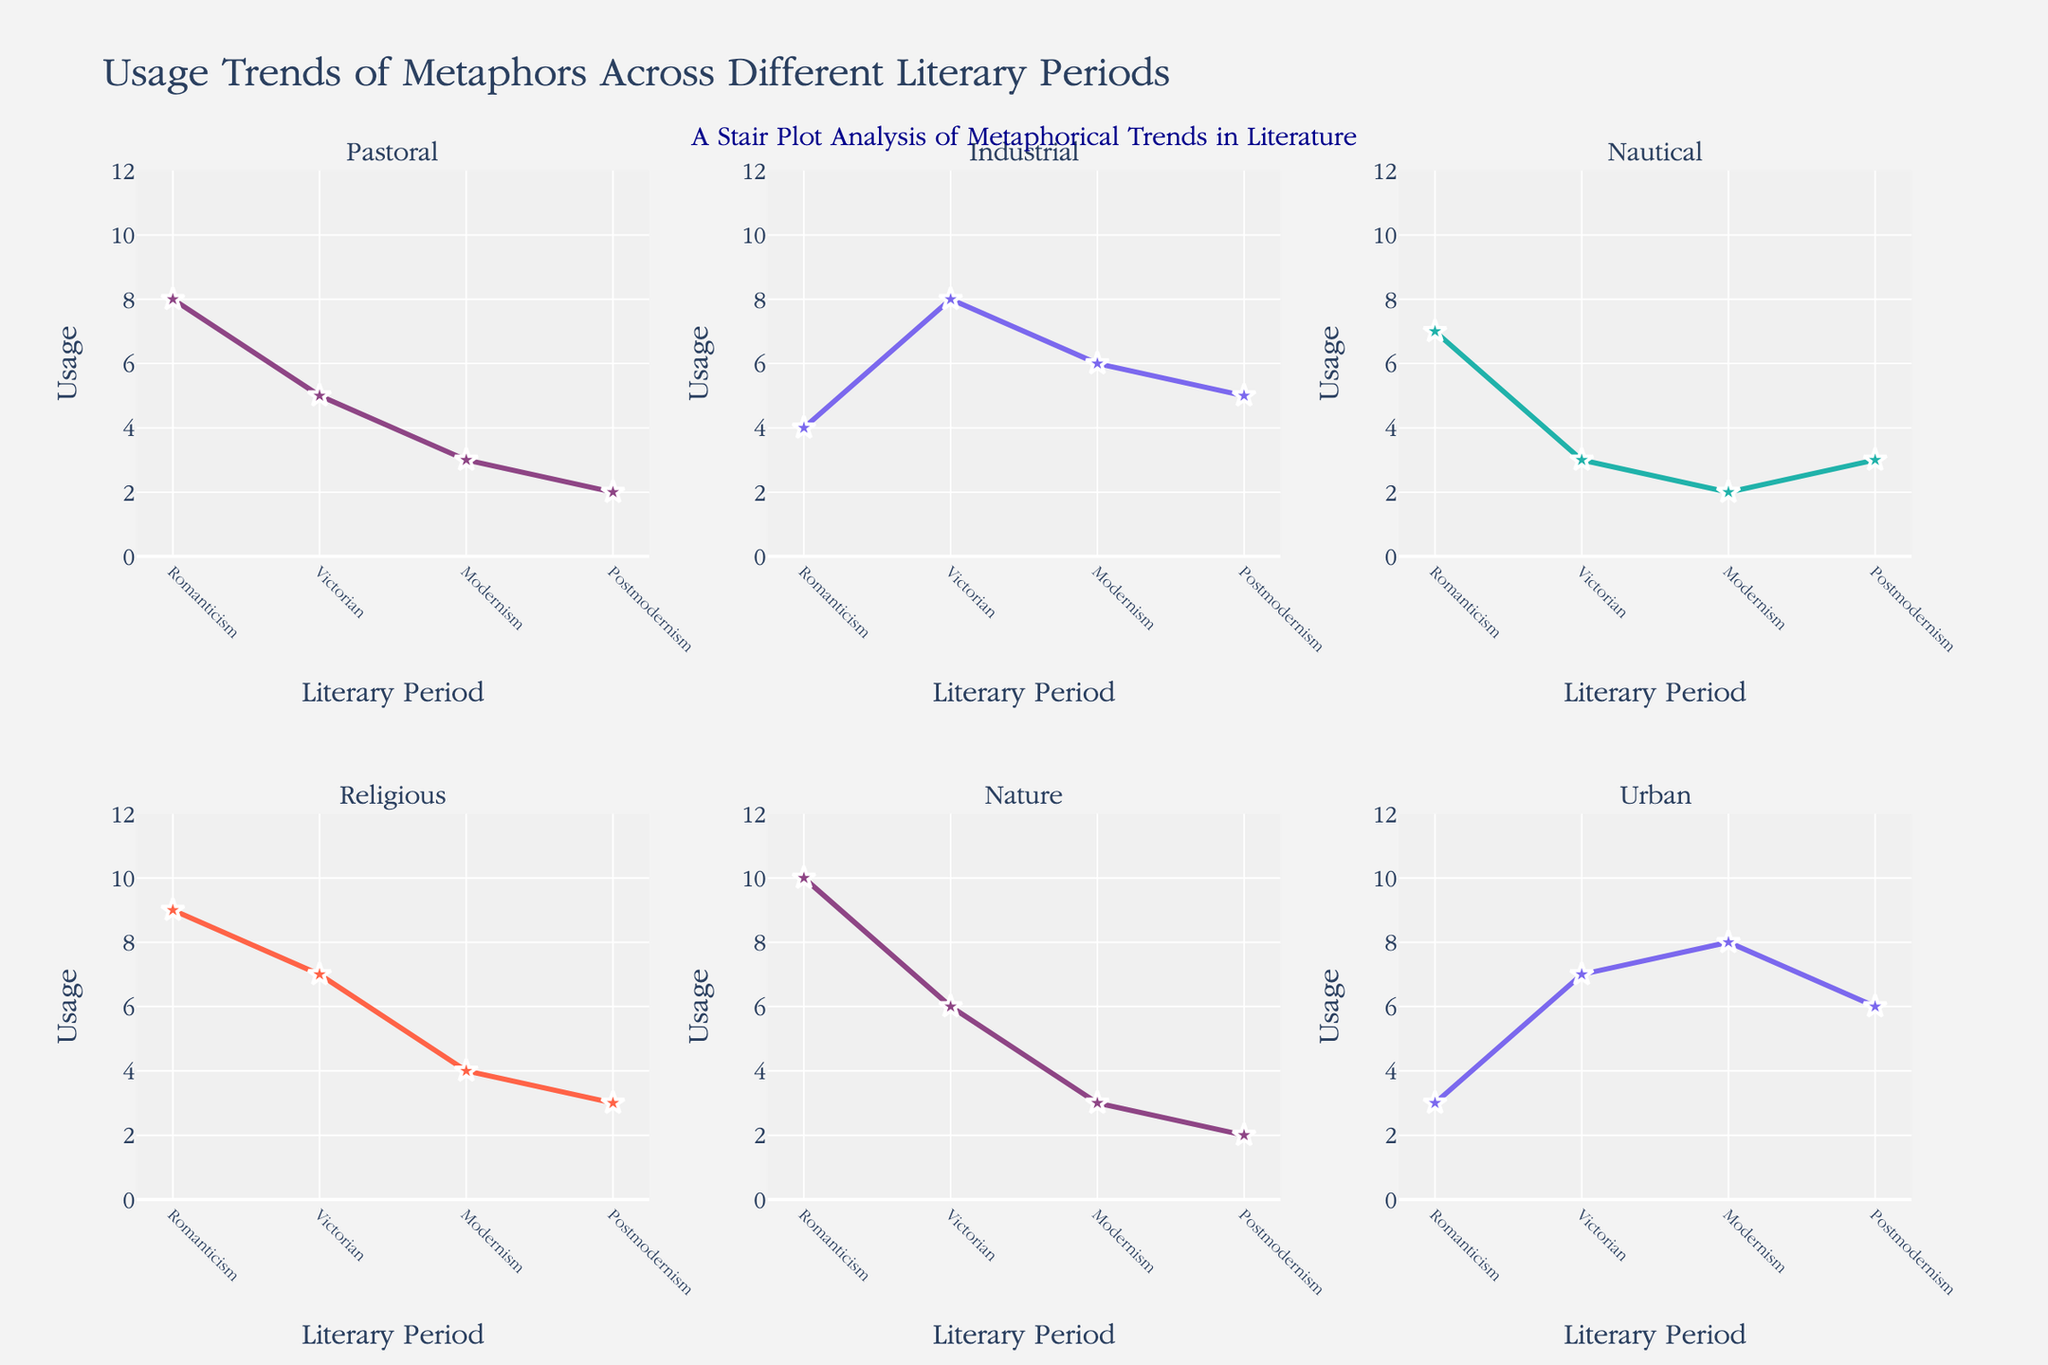What is the title of the figure? The title is displayed at the top of the figure. It reads "Usage Trends of Metaphors Across Different Literary Periods."
Answer: Usage Trends of Metaphors Across Different Literary Periods How many subplots are there in the figure? The figure has subplots arranged in a grid, identifiable by separate titles for each type of metaphor. Counting them reveals there are six subplots.
Answer: 6 What is the metaphor with the highest usage during the Romanticism period? By looking at the Romanticism column and locating the highest value, which is 10, it corresponds to the Nature metaphor.
Answer: Nature Which metaphor shows a steady decrease in usage from the Romanticism to the Postmodernism period? Observing each metaphor's trend line, the Nature and Religious metaphors both show a steady decrease throughout the periods.
Answer: Nature, Religious Which literary period shows the highest usage of Industrial metaphors? Checking the plot corresponding to Industrial metaphors and finding the peak point indicates that the highest usage is during the Victorian period with a value of 8.
Answer: Victorian What is the average usage of Nautical metaphors over all periods? Summing the values for Nautical metaphors:
7 (Romanticism) + 3 (Victorian) + 2 (Modernism) + 3 (Postmodernism) = 15. The average is 15 / 4 = 3.75.
Answer: 3.75 Compare the usage of Urban metaphors in the Victorian and Modernism periods. Which period has higher usage and by how much? The Victorian period usage is 7 and the Modernism period usage is 8. The Modernism period has a higher usage by 8 - 7 = 1.
Answer: Modernism, 1 What is the combined metaphors usage value for the Postmodernism period? Summing values for all metaphors in Postmodernism:
2 (Pastoral) + 5 (Industrial) + 3 (Nautical) + 3 (Religious) + 2 (Nature) + 6 (Urban) = 21.
Answer: 21 Which metaphor maintained the same usage between two consecutive periods, and in which periods? Reviewing all metaphor trends, the Nautical metaphor maintains the same value of 3 between the Victorian and Postmodernism periods.
Answer: Nautical, Victorian and Postmodernism 